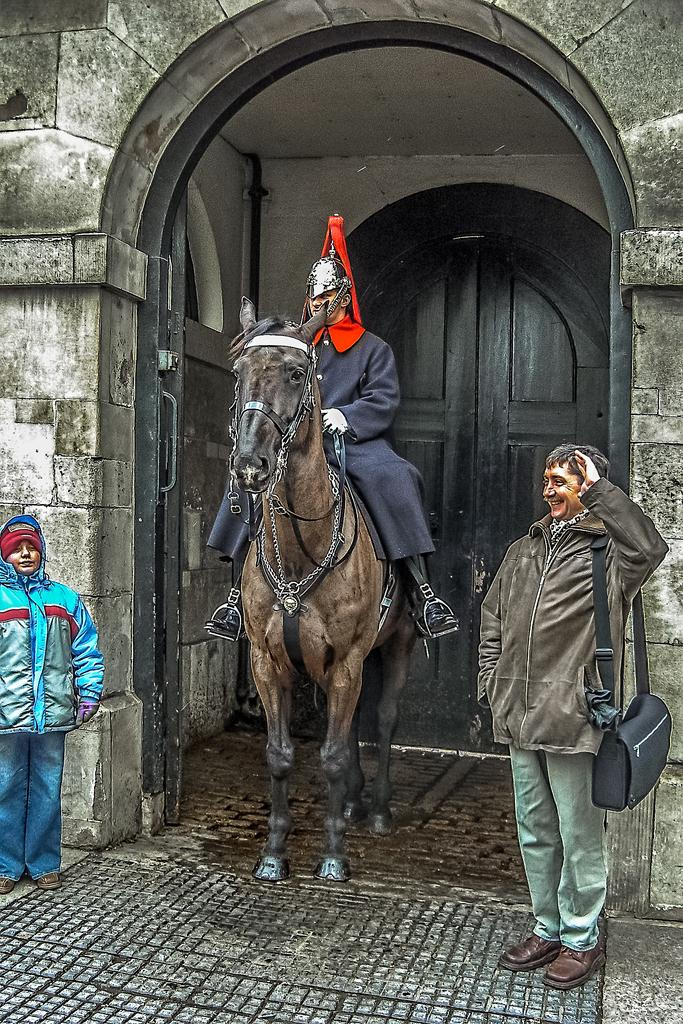What is the man in the image doing? The man is sitting on a horse in the image. Are there any other people in the image? Yes, there are two people standing beside the man on the horse. What can be seen in the background of the image? There is a door and a wall visible in the background of the image. How many snakes are wrapped around the man's stomach in the image? There are no snakes present in the image; the man is sitting on a horse. 